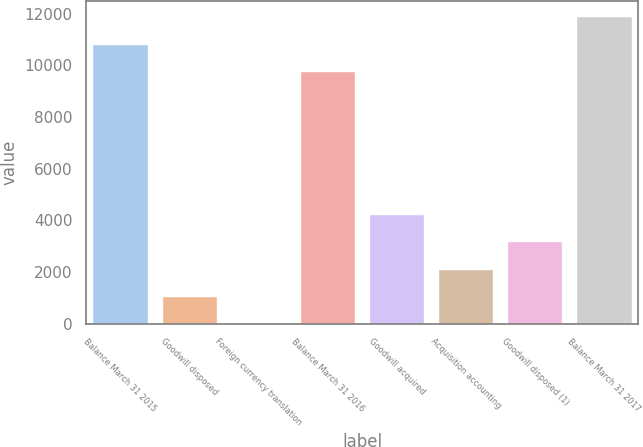Convert chart to OTSL. <chart><loc_0><loc_0><loc_500><loc_500><bar_chart><fcel>Balance March 31 2015<fcel>Goodwill disposed<fcel>Foreign currency translation<fcel>Balance March 31 2016<fcel>Goodwill acquired<fcel>Acquisition accounting<fcel>Goodwill disposed (1)<fcel>Balance March 31 2017<nl><fcel>10842<fcel>1082<fcel>26<fcel>9786<fcel>4250<fcel>2138<fcel>3194<fcel>11898<nl></chart> 